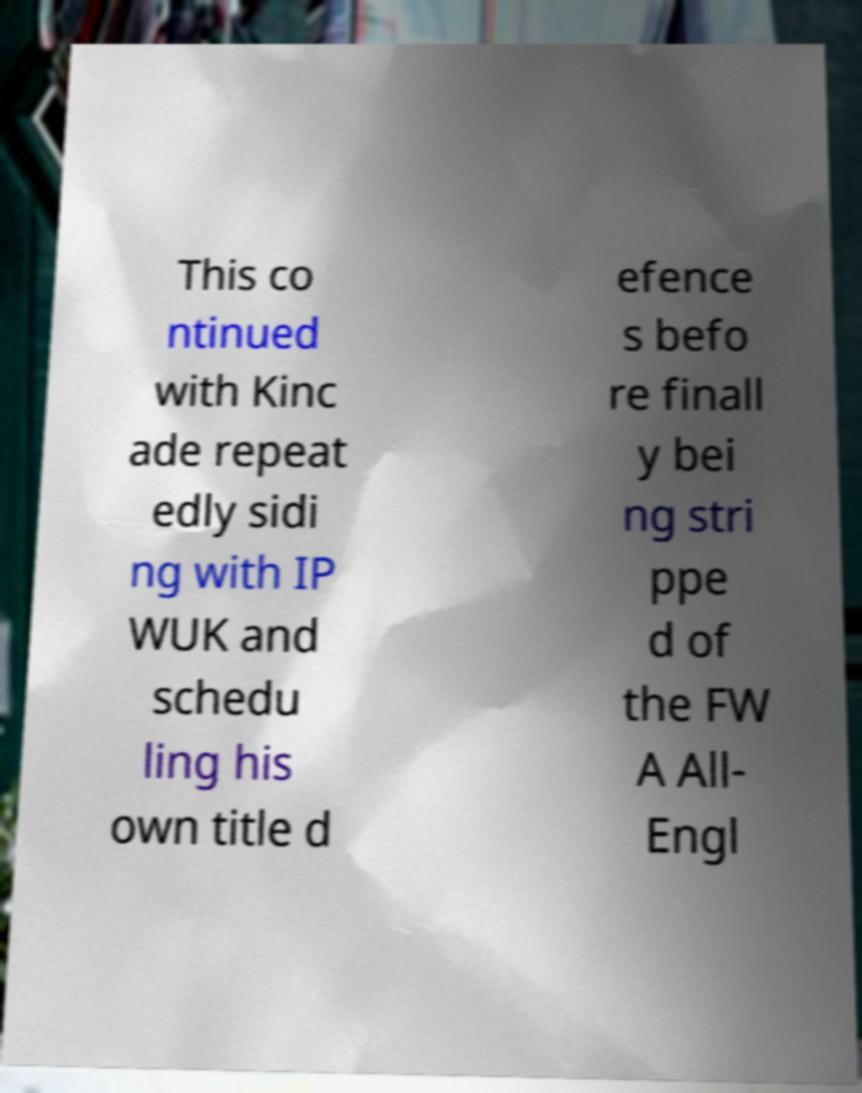Can you read and provide the text displayed in the image?This photo seems to have some interesting text. Can you extract and type it out for me? This co ntinued with Kinc ade repeat edly sidi ng with IP WUK and schedu ling his own title d efence s befo re finall y bei ng stri ppe d of the FW A All- Engl 